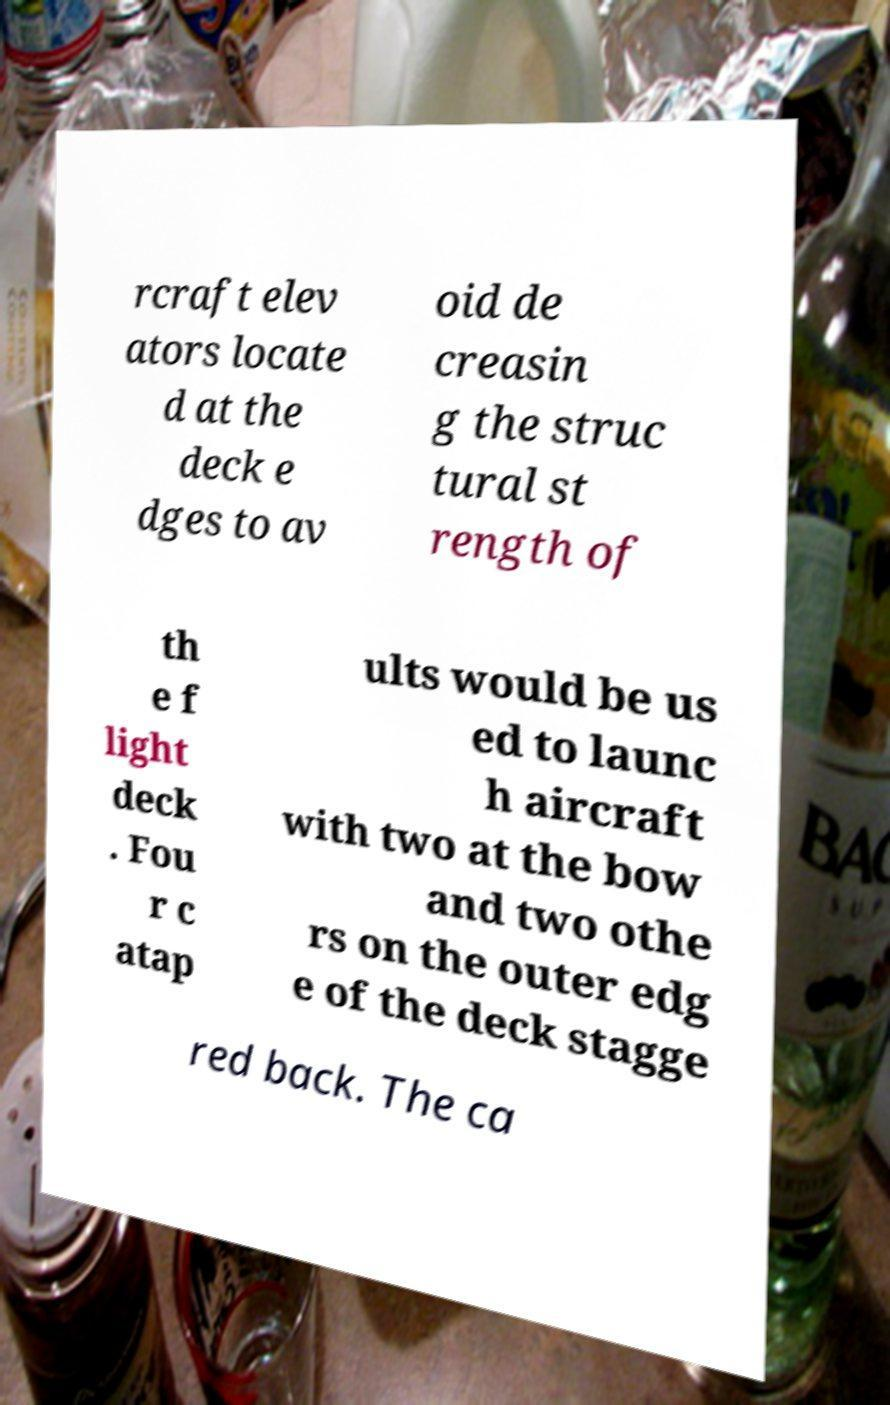Could you assist in decoding the text presented in this image and type it out clearly? rcraft elev ators locate d at the deck e dges to av oid de creasin g the struc tural st rength of th e f light deck . Fou r c atap ults would be us ed to launc h aircraft with two at the bow and two othe rs on the outer edg e of the deck stagge red back. The ca 